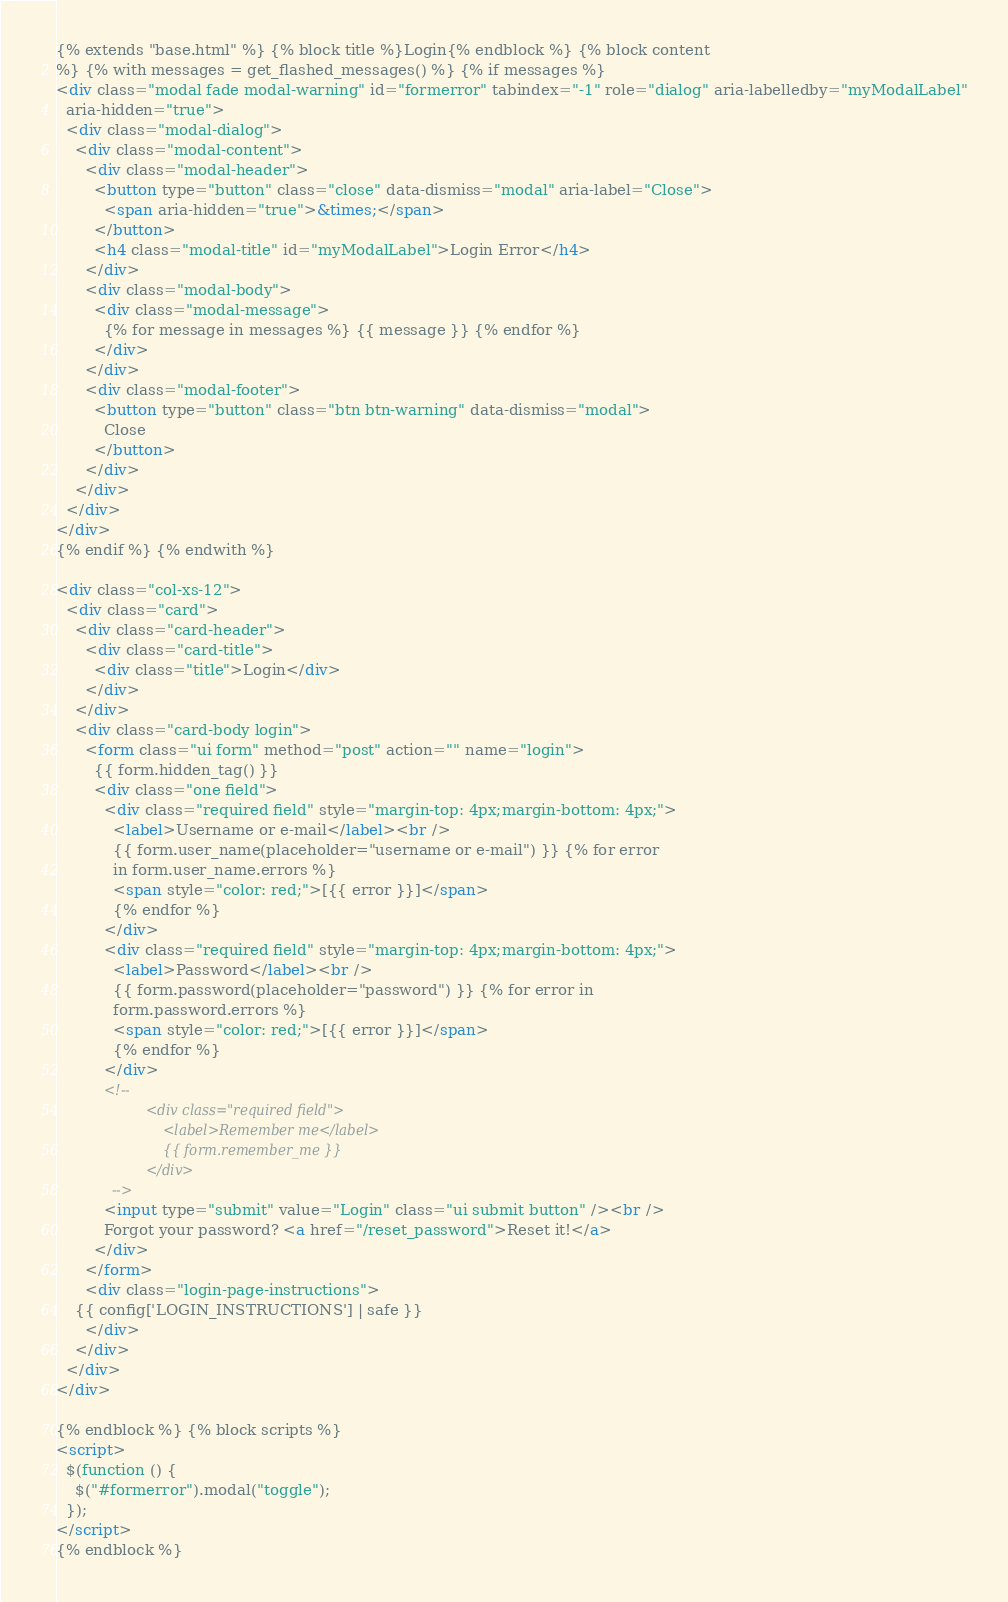Convert code to text. <code><loc_0><loc_0><loc_500><loc_500><_HTML_>{% extends "base.html" %} {% block title %}Login{% endblock %} {% block content
%} {% with messages = get_flashed_messages() %} {% if messages %}
<div class="modal fade modal-warning" id="formerror" tabindex="-1" role="dialog" aria-labelledby="myModalLabel"
  aria-hidden="true">
  <div class="modal-dialog">
    <div class="modal-content">
      <div class="modal-header">
        <button type="button" class="close" data-dismiss="modal" aria-label="Close">
          <span aria-hidden="true">&times;</span>
        </button>
        <h4 class="modal-title" id="myModalLabel">Login Error</h4>
      </div>
      <div class="modal-body">
        <div class="modal-message">
          {% for message in messages %} {{ message }} {% endfor %}
        </div>
      </div>
      <div class="modal-footer">
        <button type="button" class="btn btn-warning" data-dismiss="modal">
          Close
        </button>
      </div>
    </div>
  </div>
</div>
{% endif %} {% endwith %}

<div class="col-xs-12">
  <div class="card">
    <div class="card-header">
      <div class="card-title">
        <div class="title">Login</div>
      </div>
    </div>
    <div class="card-body login">
      <form class="ui form" method="post" action="" name="login">
        {{ form.hidden_tag() }}
        <div class="one field">
          <div class="required field" style="margin-top: 4px;margin-bottom: 4px;">
            <label>Username or e-mail</label><br />
            {{ form.user_name(placeholder="username or e-mail") }} {% for error
            in form.user_name.errors %}
            <span style="color: red;">[{{ error }}]</span>
            {% endfor %}
          </div>
          <div class="required field" style="margin-top: 4px;margin-bottom: 4px;">
            <label>Password</label><br />
            {{ form.password(placeholder="password") }} {% for error in
            form.password.errors %}
            <span style="color: red;">[{{ error }}]</span>
            {% endfor %}
          </div>
          <!--
                     <div class="required field">
                         <label>Remember me</label>
                         {{ form.remember_me }}
                     </div>
             -->
          <input type="submit" value="Login" class="ui submit button" /><br />
          Forgot your password? <a href="/reset_password">Reset it!</a>
        </div>
      </form>
      <div class="login-page-instructions">
	{{ config['LOGIN_INSTRUCTIONS'] | safe }}
      </div>
    </div>
  </div>
</div>

{% endblock %} {% block scripts %}
<script>
  $(function () {
    $("#formerror").modal("toggle");
  });
</script>
{% endblock %}
</code> 